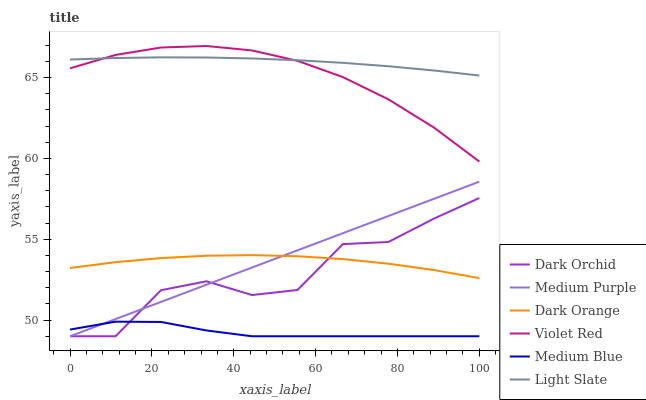Does Violet Red have the minimum area under the curve?
Answer yes or no. No. Does Violet Red have the maximum area under the curve?
Answer yes or no. No. Is Violet Red the smoothest?
Answer yes or no. No. Is Violet Red the roughest?
Answer yes or no. No. Does Violet Red have the lowest value?
Answer yes or no. No. Does Light Slate have the highest value?
Answer yes or no. No. Is Medium Blue less than Light Slate?
Answer yes or no. Yes. Is Violet Red greater than Dark Orchid?
Answer yes or no. Yes. Does Medium Blue intersect Light Slate?
Answer yes or no. No. 